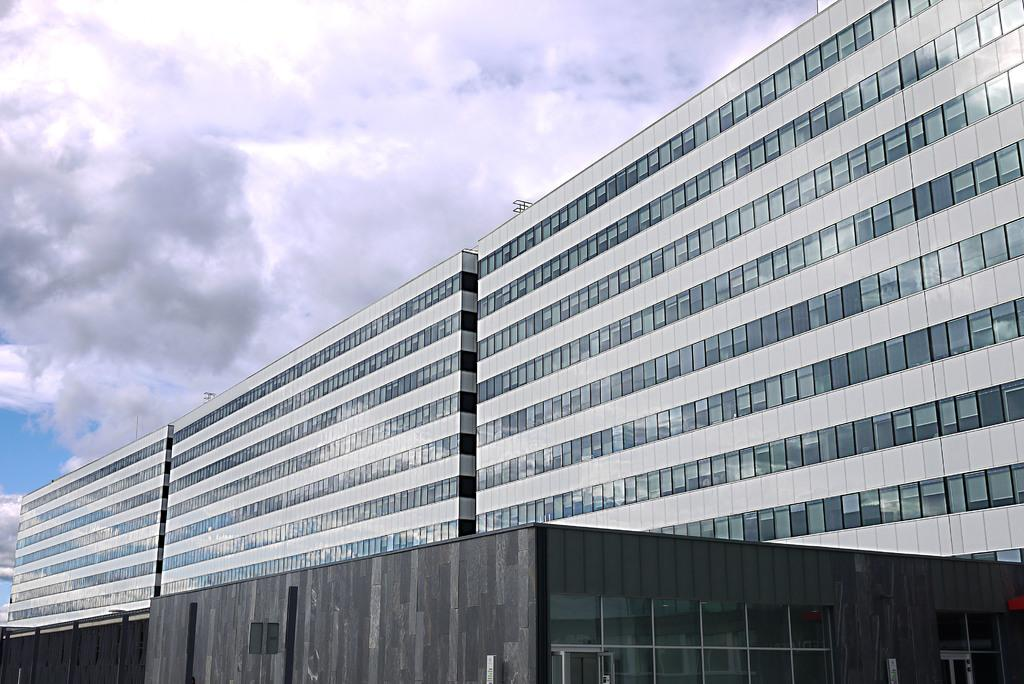What type of structures can be seen in the image? There are buildings in the image. What colors are the buildings? The buildings are in gray and black colors. What can be seen in the background of the image? The sky is visible in the background of the image. What colors are the sky? The sky is in white and blue colors. How does the blade of grass affect the credit score of the buildings in the image? There is no blade of grass or credit score mentioned in the image, so it is not possible to answer that question. 